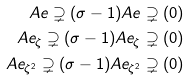<formula> <loc_0><loc_0><loc_500><loc_500>A e \supsetneq ( \sigma - 1 ) A e \supsetneq ( 0 ) \\ A e _ { \zeta } \supsetneq ( \sigma - 1 ) A e _ { \zeta } \supsetneq ( 0 ) \\ A e _ { \zeta ^ { 2 } } \supsetneq ( \sigma - 1 ) A e _ { \zeta ^ { 2 } } \supsetneq ( 0 )</formula> 